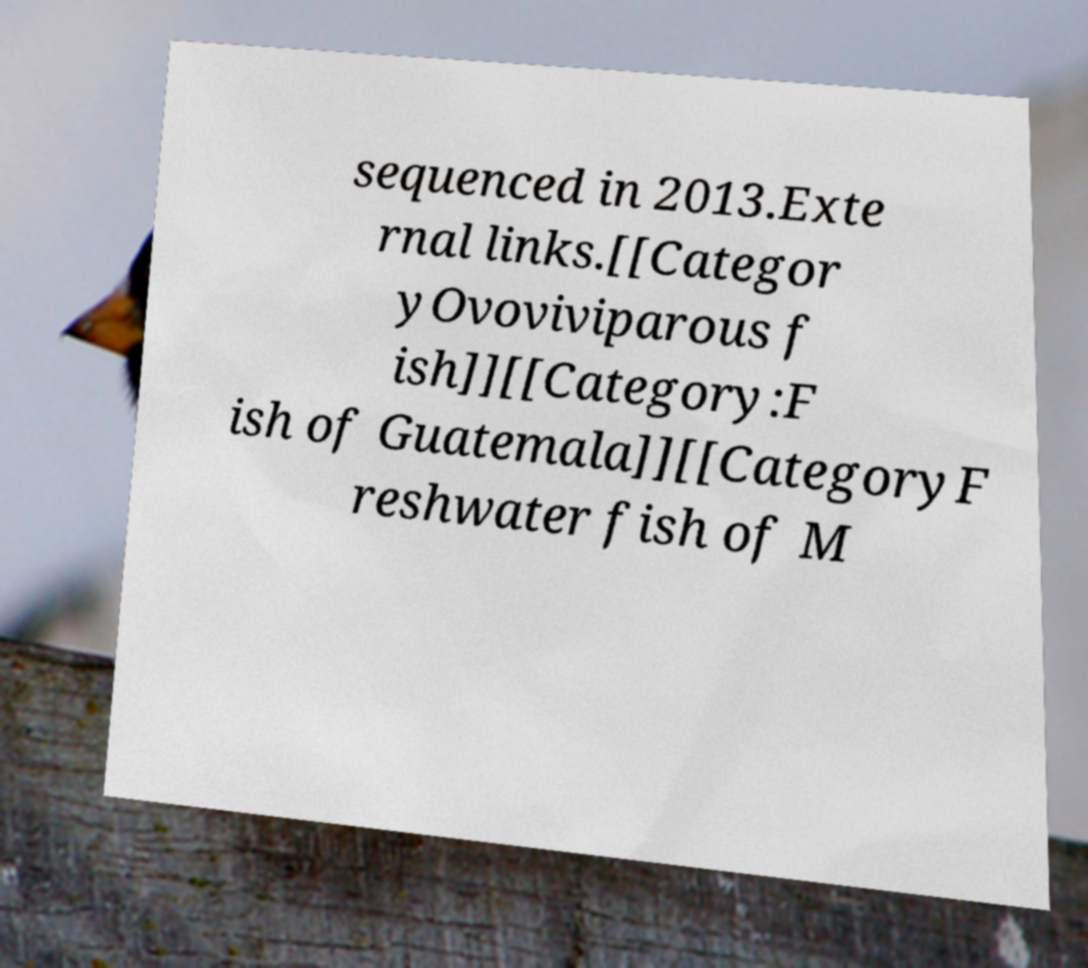Could you extract and type out the text from this image? sequenced in 2013.Exte rnal links.[[Categor yOvoviviparous f ish]][[Category:F ish of Guatemala]][[CategoryF reshwater fish of M 